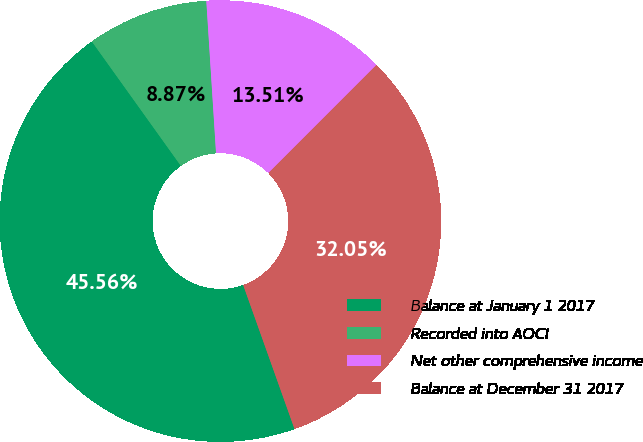Convert chart to OTSL. <chart><loc_0><loc_0><loc_500><loc_500><pie_chart><fcel>Balance at January 1 2017<fcel>Recorded into AOCI<fcel>Net other comprehensive income<fcel>Balance at December 31 2017<nl><fcel>45.56%<fcel>8.87%<fcel>13.51%<fcel>32.05%<nl></chart> 